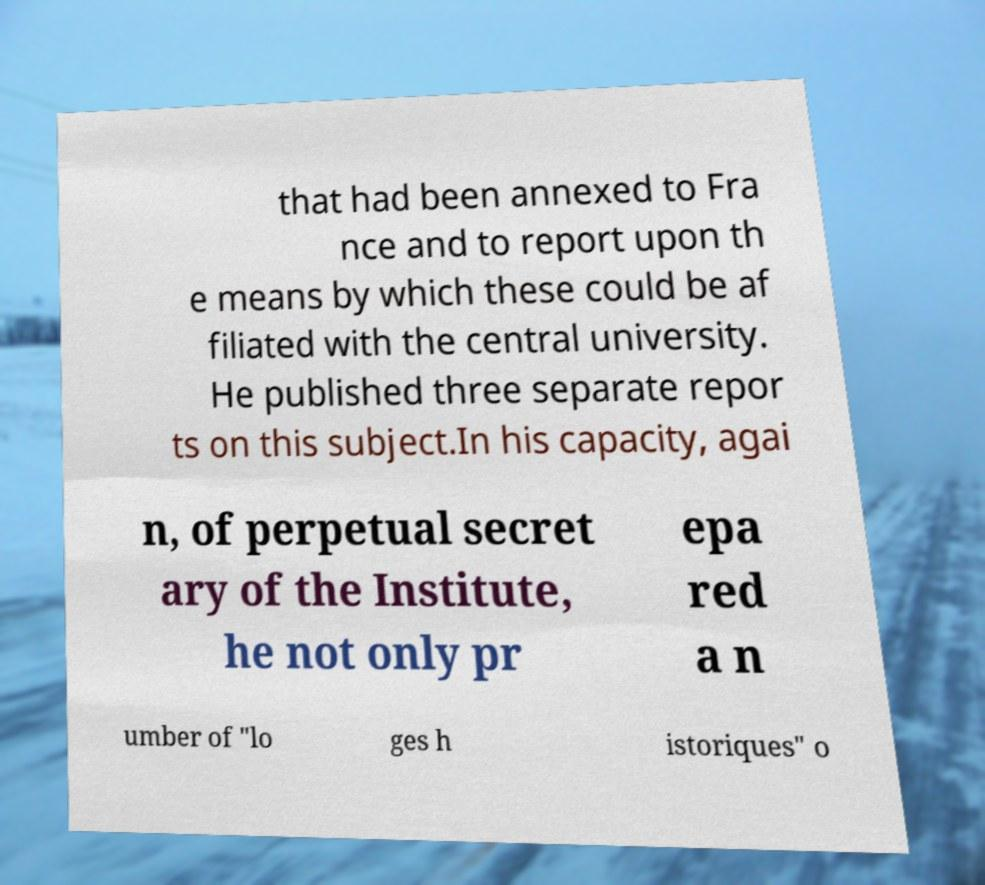There's text embedded in this image that I need extracted. Can you transcribe it verbatim? that had been annexed to Fra nce and to report upon th e means by which these could be af filiated with the central university. He published three separate repor ts on this subject.In his capacity, agai n, of perpetual secret ary of the Institute, he not only pr epa red a n umber of "lo ges h istoriques" o 